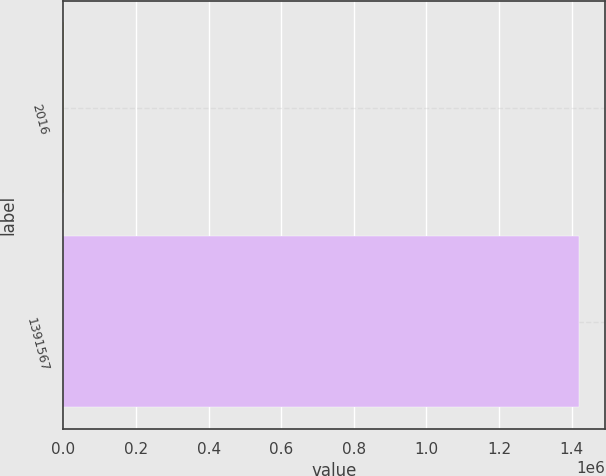Convert chart. <chart><loc_0><loc_0><loc_500><loc_500><bar_chart><fcel>2016<fcel>1391567<nl><fcel>2015<fcel>1.42151e+06<nl></chart> 